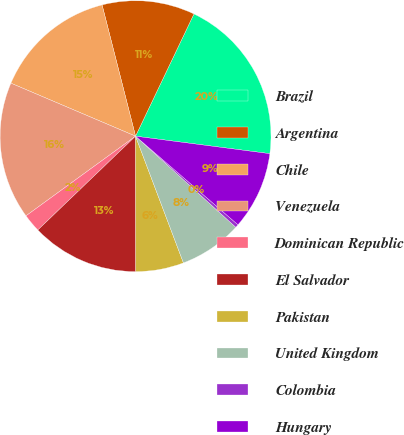Convert chart. <chart><loc_0><loc_0><loc_500><loc_500><pie_chart><fcel>Brazil<fcel>Argentina<fcel>Chile<fcel>Venezuela<fcel>Dominican Republic<fcel>El Salvador<fcel>Pakistan<fcel>United Kingdom<fcel>Colombia<fcel>Hungary<nl><fcel>19.97%<fcel>11.07%<fcel>14.63%<fcel>16.41%<fcel>2.17%<fcel>12.85%<fcel>5.73%<fcel>7.51%<fcel>0.39%<fcel>9.29%<nl></chart> 